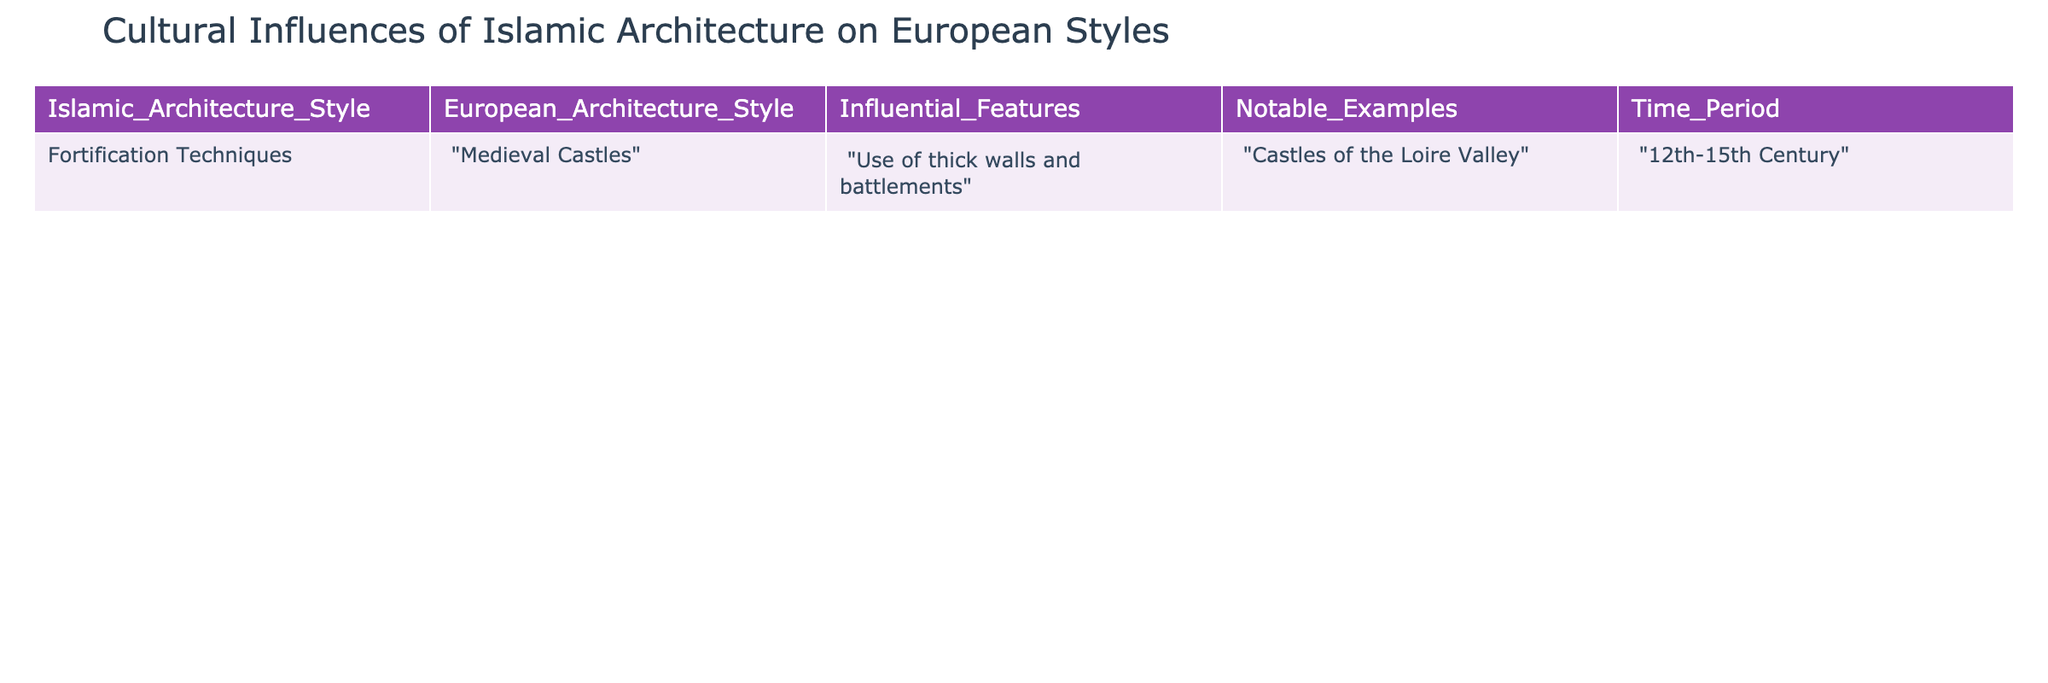What is the influential feature shared between Islamic architecture and medieval castles? The table lists "Use of thick walls and battlements" as the influential feature shared between Islamic architecture styles and European medieval castles. This can be found directly in the "Influential Features" column.
Answer: Use of thick walls and battlements What notable examples are provided for the influence of Islamic architecture on European styles? The table mentions "Castles of the Loire Valley" as a notable example of the influence of Islamic architecture on European styles, which is found in the "Notable Examples" column.
Answer: Castles of the Loire Valley During which time period did the Islamic architectural influence on medieval castles occur? According to the "Time Period" column in the table, the influence occurred from the 12th to the 15th century. This is directly stated in the relevant row.
Answer: 12th-15th Century Is it true that the fortification techniques from Islamic architecture influenced European styles? Yes, the data clearly indicates that "Fortification Techniques" in Islamic architecture did influence European architecture, as shown in the table.
Answer: Yes How many different architectural styles are represented in the table? The table includes two architectural styles: "Fortification Techniques" from Islamic architecture and "Medieval Castles" from European architecture. Therefore, the count is based on the distinct entries listed.
Answer: 2 What could be inferred about the relationship between Islamic architecture and European castle design based on the influential feature? The shared feature of thick walls and battlements suggests that Islamic architecture may have provided practical military design insights that were adopted in European castles for defense purposes. This is inferred by analyzing the data partnerships between the two architectural styles.
Answer: Islamic architecture influenced military design in European castles Is the use of battlements exclusive to medieval castles only? No, the use of battlements is a characteristic found in various forms of fortifications and is not exclusive to medieval castles, so the statement is false when considering the broader context of architecture.
Answer: No What logical connection can be made about time periods between Islamic architecture and European styles? The time period noted (12th-15th Century) indicates a period of intercultural exchange when Islamic architectural methods were prevalent, suggesting that this era mark significant architectural influences, reflecting a logical connection of ongoing cultural interchange, as shown by the dates provided.
Answer: Significant intercultural exchange occurred 